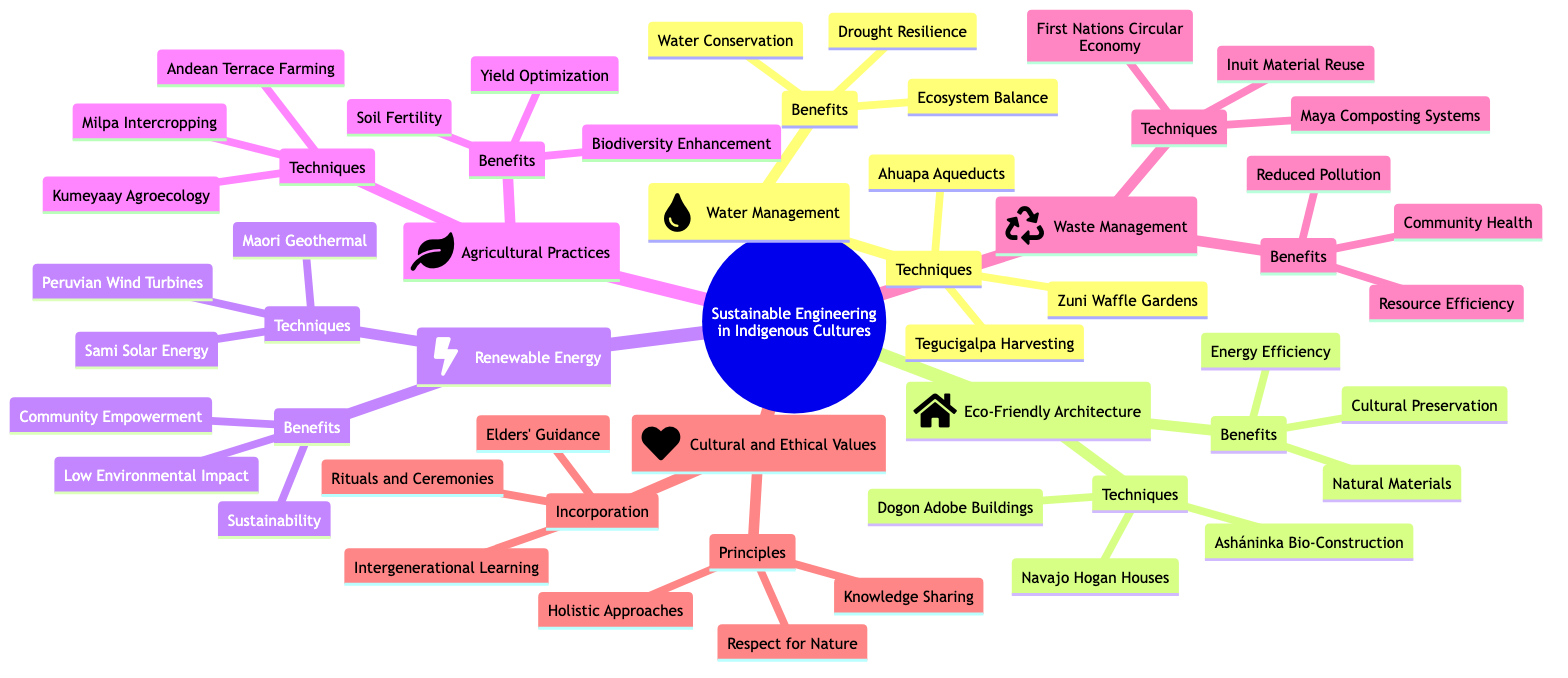What is the main topic of the mind map? The main node clearly states "Sustainable Engineering Practices Rooted in Indigenous Cultures", which represents the overarching theme of the diagram.
Answer: Sustainable Engineering Practices Rooted in Indigenous Cultures How many techniques are listed under Renewable Energy Systems? In the Renewable Energy subtopic, there are three specific techniques presented: Peruvian Wind Turbines, Sami Solar Energy, and Maori Geothermal Utilization, leading to the total of three techniques.
Answer: 3 What are the benefits associated with Eco-Friendly Architecture? The Eco-Friendly Architecture section lists three benefits: Energy Efficiency, Natural Materials, and Cultural Preservation. These benefits are connected to the techniques mentioned under this subtopic.
Answer: Energy Efficiency, Natural Materials, Cultural Preservation Which cultural value is included under Cultural and Ethical Values? Within the Cultural and Ethical Values section, "Respect for Nature" is one of the three principles stated. This emphasizes the core values associated with indigenous engineering practices.
Answer: Respect for Nature How many main subtopics are there in the mind map? The mind map outlines six main subtopics, each pertaining to different aspects of sustainable engineering practices rooted in indigenous cultures, confirming the total count.
Answer: 6 What technique is related to Waste Management? Under the Waste Management subtopic, "Maya Composting Systems" is identified as one of the techniques aimed at promoting sustainable waste management practices.
Answer: Maya Composting Systems Which technique is listed first under Traditional Water Management? The first technique mentioned in the Traditional Water Management section is "Ahuapa Aqueducts", which highlights an indigenous approach to managing water resources effectively.
Answer: Ahuapa Aqueducts What is emphasized in the incorporation of Cultural and Ethical Values? In the incorporation aspect of Cultural and Ethical Values, "Elders' Guidance" is highlighted, showing the significance of knowledge passed down through generations in indigenous practices.
Answer: Elders' Guidance Which benefit is associated with Agricultural Practices? Among the benefits listed under Agricultural Practices, "Soil Fertility" is specifically mentioned as one of the key advantages derived from the indigenous agricultural techniques.
Answer: Soil Fertility 